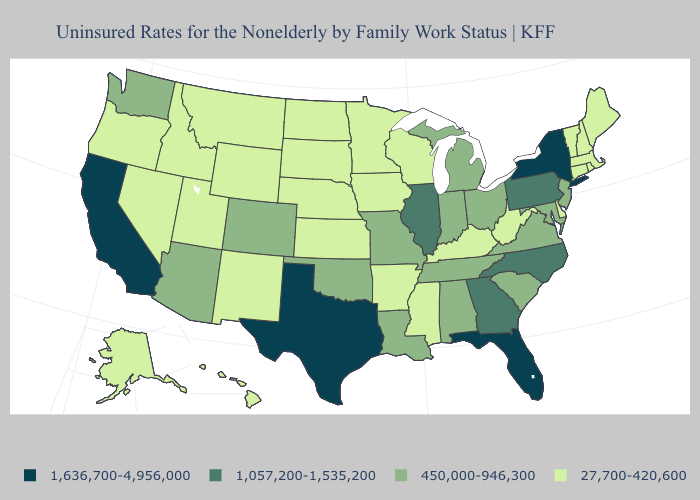Does Texas have the highest value in the USA?
Quick response, please. Yes. What is the lowest value in the MidWest?
Write a very short answer. 27,700-420,600. What is the value of New Hampshire?
Concise answer only. 27,700-420,600. Does New York have the highest value in the USA?
Quick response, please. Yes. What is the value of Pennsylvania?
Quick response, please. 1,057,200-1,535,200. What is the highest value in the West ?
Answer briefly. 1,636,700-4,956,000. Which states hav the highest value in the MidWest?
Answer briefly. Illinois. Does Nebraska have the same value as South Carolina?
Quick response, please. No. What is the value of Pennsylvania?
Be succinct. 1,057,200-1,535,200. What is the value of Florida?
Concise answer only. 1,636,700-4,956,000. Name the states that have a value in the range 1,057,200-1,535,200?
Keep it brief. Georgia, Illinois, North Carolina, Pennsylvania. Does Illinois have the same value as North Carolina?
Be succinct. Yes. Does Florida have the highest value in the South?
Concise answer only. Yes. What is the value of Georgia?
Answer briefly. 1,057,200-1,535,200. What is the highest value in the West ?
Give a very brief answer. 1,636,700-4,956,000. 